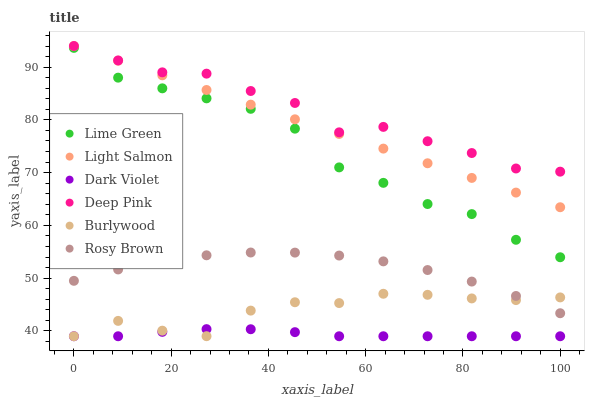Does Dark Violet have the minimum area under the curve?
Answer yes or no. Yes. Does Deep Pink have the maximum area under the curve?
Answer yes or no. Yes. Does Burlywood have the minimum area under the curve?
Answer yes or no. No. Does Burlywood have the maximum area under the curve?
Answer yes or no. No. Is Light Salmon the smoothest?
Answer yes or no. Yes. Is Deep Pink the roughest?
Answer yes or no. Yes. Is Burlywood the smoothest?
Answer yes or no. No. Is Burlywood the roughest?
Answer yes or no. No. Does Burlywood have the lowest value?
Answer yes or no. Yes. Does Deep Pink have the lowest value?
Answer yes or no. No. Does Deep Pink have the highest value?
Answer yes or no. Yes. Does Burlywood have the highest value?
Answer yes or no. No. Is Dark Violet less than Rosy Brown?
Answer yes or no. Yes. Is Light Salmon greater than Burlywood?
Answer yes or no. Yes. Does Deep Pink intersect Light Salmon?
Answer yes or no. Yes. Is Deep Pink less than Light Salmon?
Answer yes or no. No. Is Deep Pink greater than Light Salmon?
Answer yes or no. No. Does Dark Violet intersect Rosy Brown?
Answer yes or no. No. 